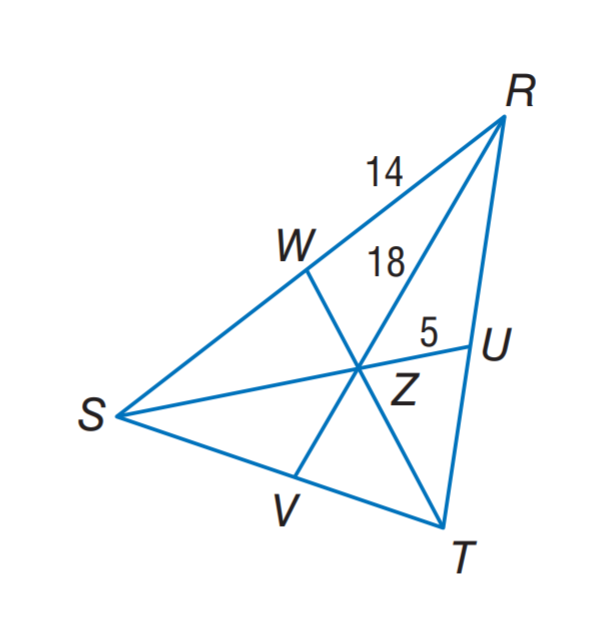Question: In \triangle R S T, Z is the centroid and R Z = 18. Find S R.
Choices:
A. 10
B. 14
C. 18
D. 28
Answer with the letter. Answer: D Question: In \triangle R S T, Z is the centroid and R Z = 18. Find S Z.
Choices:
A. 5
B. 9
C. 10
D. 18
Answer with the letter. Answer: C Question: In \triangle R S T, Z is the centroid and R Z = 18. Find Z V.
Choices:
A. 5
B. 9
C. 10
D. 18
Answer with the letter. Answer: B 